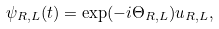Convert formula to latex. <formula><loc_0><loc_0><loc_500><loc_500>\psi _ { R , L } ( t ) = \exp ( - i \Theta _ { R , L } ) u _ { R , L } ,</formula> 